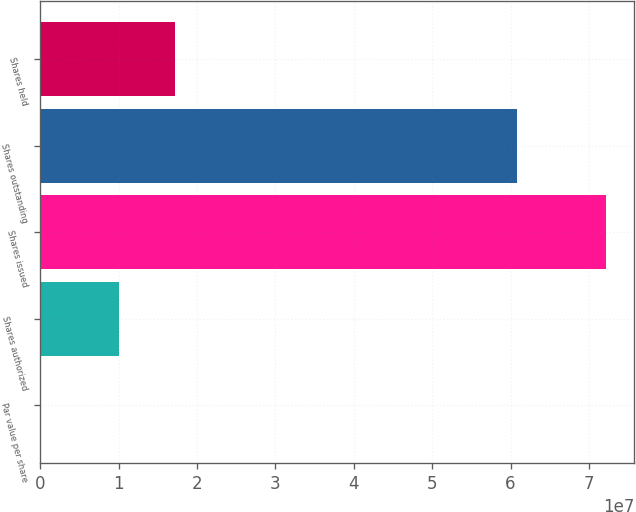Convert chart to OTSL. <chart><loc_0><loc_0><loc_500><loc_500><bar_chart><fcel>Par value per share<fcel>Shares authorized<fcel>Shares issued<fcel>Shares outstanding<fcel>Shares held<nl><fcel>0.01<fcel>1e+07<fcel>7.21519e+07<fcel>6.08616e+07<fcel>1.72152e+07<nl></chart> 